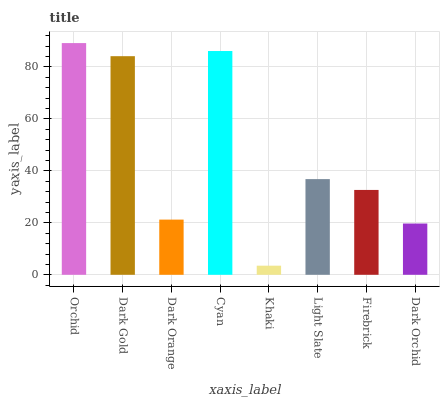Is Khaki the minimum?
Answer yes or no. Yes. Is Orchid the maximum?
Answer yes or no. Yes. Is Dark Gold the minimum?
Answer yes or no. No. Is Dark Gold the maximum?
Answer yes or no. No. Is Orchid greater than Dark Gold?
Answer yes or no. Yes. Is Dark Gold less than Orchid?
Answer yes or no. Yes. Is Dark Gold greater than Orchid?
Answer yes or no. No. Is Orchid less than Dark Gold?
Answer yes or no. No. Is Light Slate the high median?
Answer yes or no. Yes. Is Firebrick the low median?
Answer yes or no. Yes. Is Dark Orchid the high median?
Answer yes or no. No. Is Dark Gold the low median?
Answer yes or no. No. 